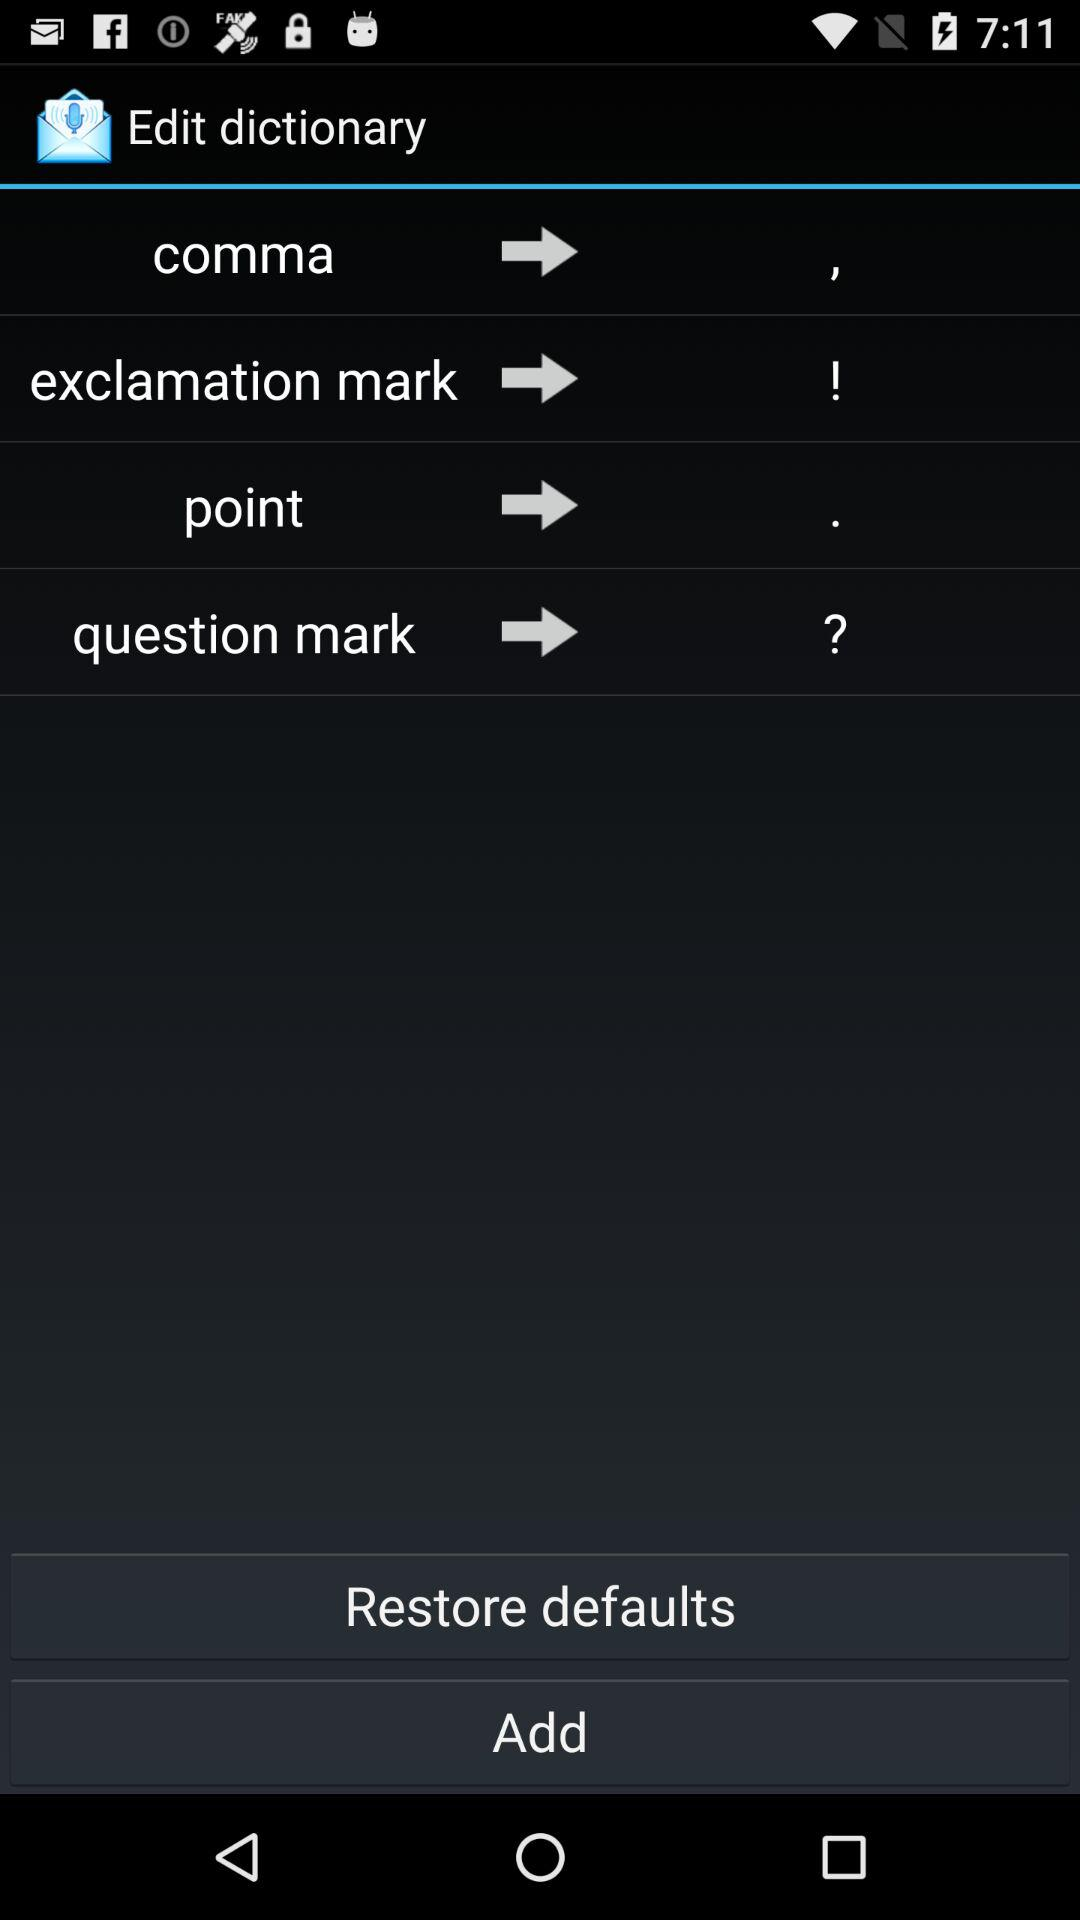What is the app name? The app name is "Edit dictionary". 